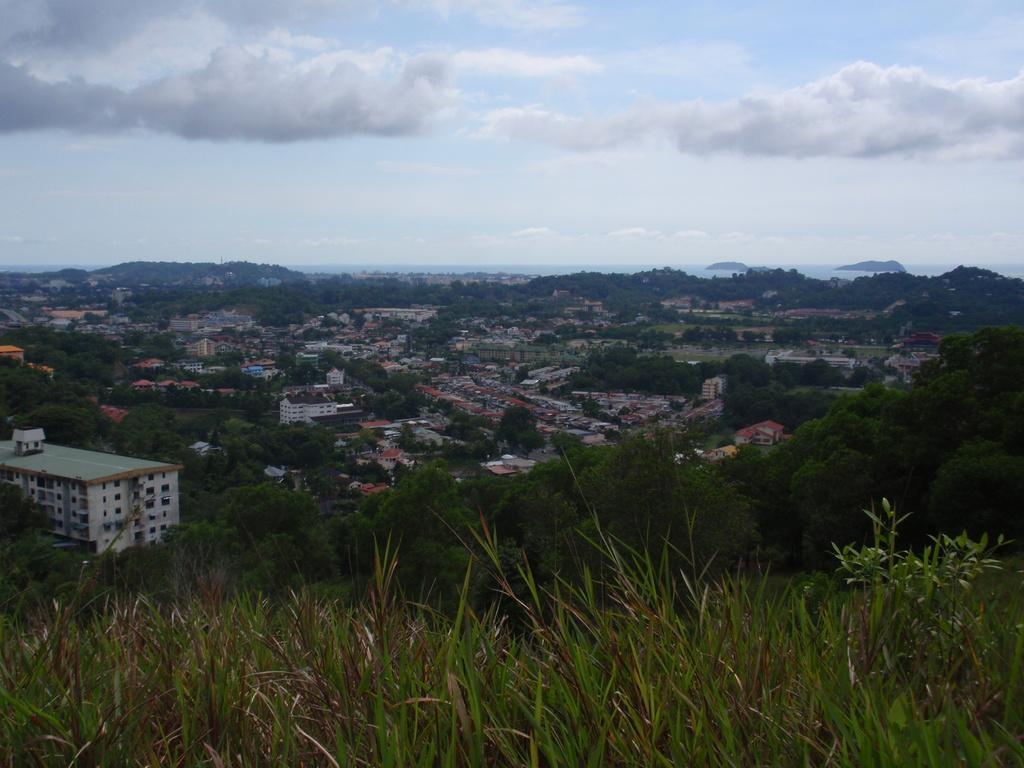What type of view is provided in the image? The image is an aerial view. What type of vegetation can be seen in the image? There are trees visible in the image. What type of structures can be seen in the image? There are houses and buildings visible in the image. What is visible in the background of the image? The sky is visible in the image. What type of furniture can be seen in the image? There is no furniture visible in the image, as it is an aerial view of an outdoor area with trees, houses, buildings, and the sky. 